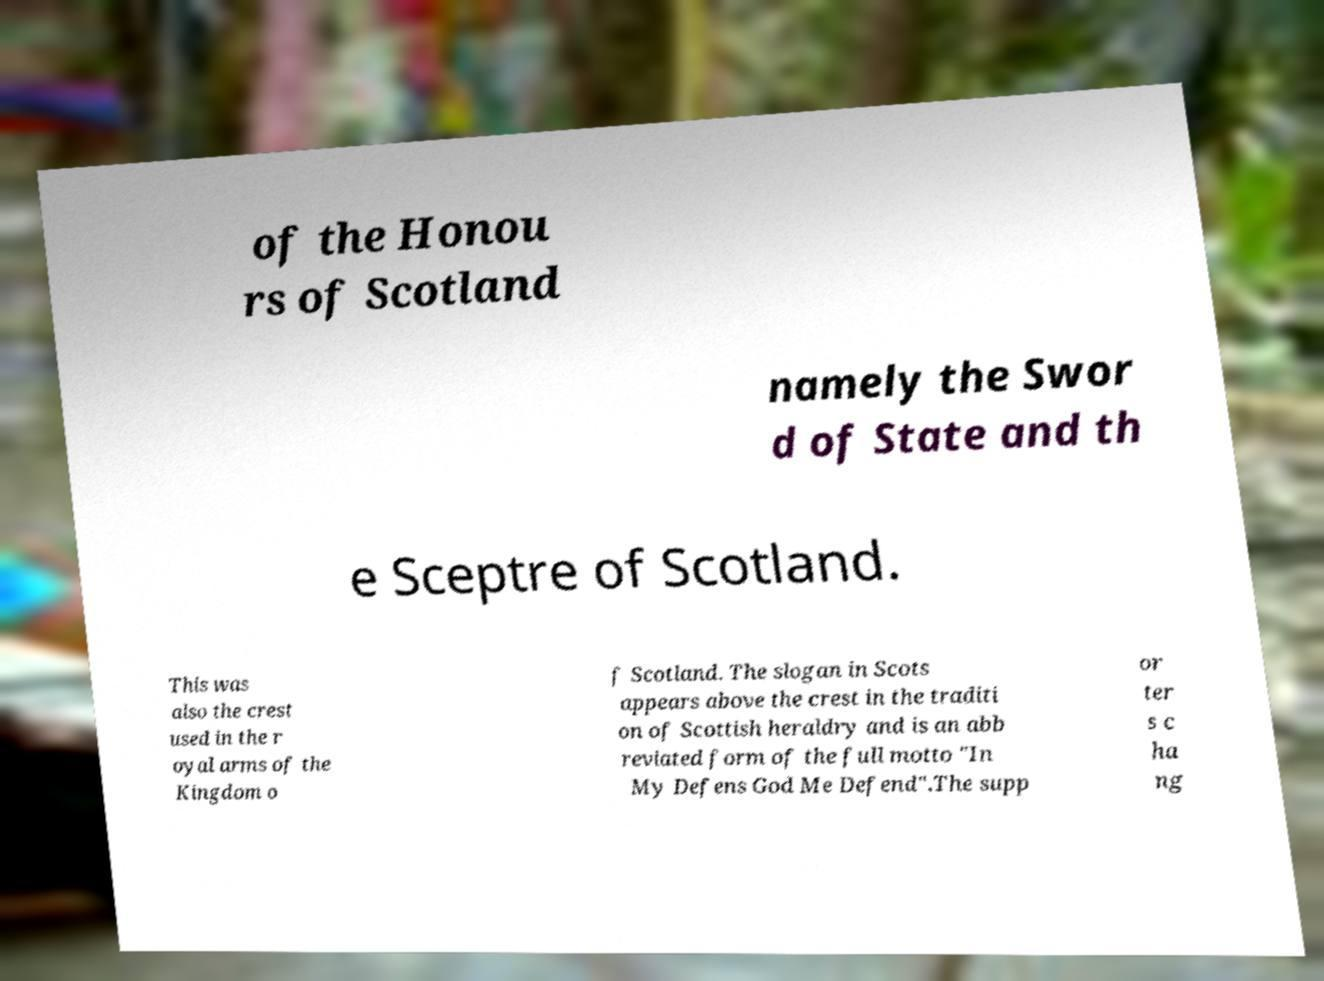Could you extract and type out the text from this image? of the Honou rs of Scotland namely the Swor d of State and th e Sceptre of Scotland. This was also the crest used in the r oyal arms of the Kingdom o f Scotland. The slogan in Scots appears above the crest in the traditi on of Scottish heraldry and is an abb reviated form of the full motto "In My Defens God Me Defend".The supp or ter s c ha ng 